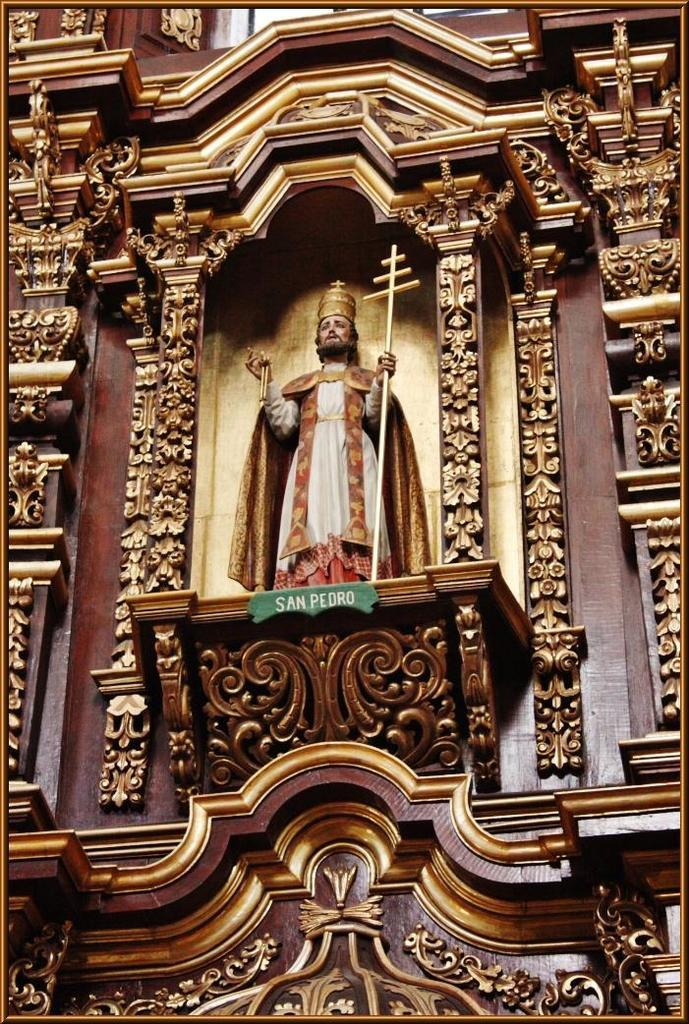What is the main subject in the image? There is a statue in the image. What else can be seen on the wall in the image? There is text and floral architecture on the wall in the image. What type of truck can be seen driving through the rhythm in the image? There is no truck or rhythm present in the image; it features a statue and text on a wall with floral architecture. 